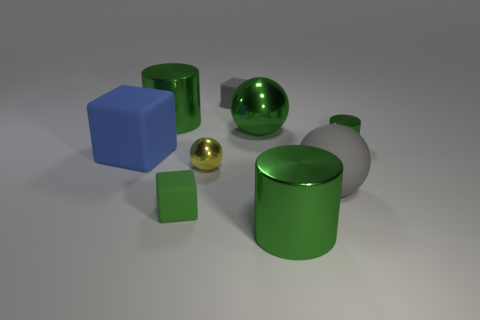How big is the metallic object that is to the right of the shiny object in front of the large gray matte sphere?
Make the answer very short. Small. There is a small matte thing that is behind the tiny yellow metal ball; is it the same color as the big matte object that is right of the small green matte thing?
Provide a succinct answer. Yes. There is a rubber thing that is right of the big matte cube and on the left side of the yellow object; what is its color?
Give a very brief answer. Green. What number of other things are there of the same shape as the blue thing?
Your response must be concise. 2. There is a matte ball that is the same size as the blue rubber object; what color is it?
Provide a succinct answer. Gray. The big metal cylinder left of the big green metallic sphere is what color?
Provide a short and direct response. Green. Are there any small green matte things that are to the right of the big cylinder to the left of the tiny gray block?
Offer a terse response. Yes. There is a tiny yellow metal object; is its shape the same as the large green thing left of the tiny yellow object?
Offer a terse response. No. What size is the metal cylinder that is to the right of the tiny yellow metal ball and on the left side of the big gray matte object?
Provide a succinct answer. Large. Is there a large green object that has the same material as the tiny green block?
Give a very brief answer. No. 